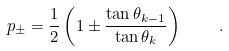<formula> <loc_0><loc_0><loc_500><loc_500>p _ { \pm } = \frac { 1 } { 2 } \left ( 1 \pm \frac { \tan \theta _ { k - 1 } } { \tan \theta _ { k } } \right ) \quad .</formula> 